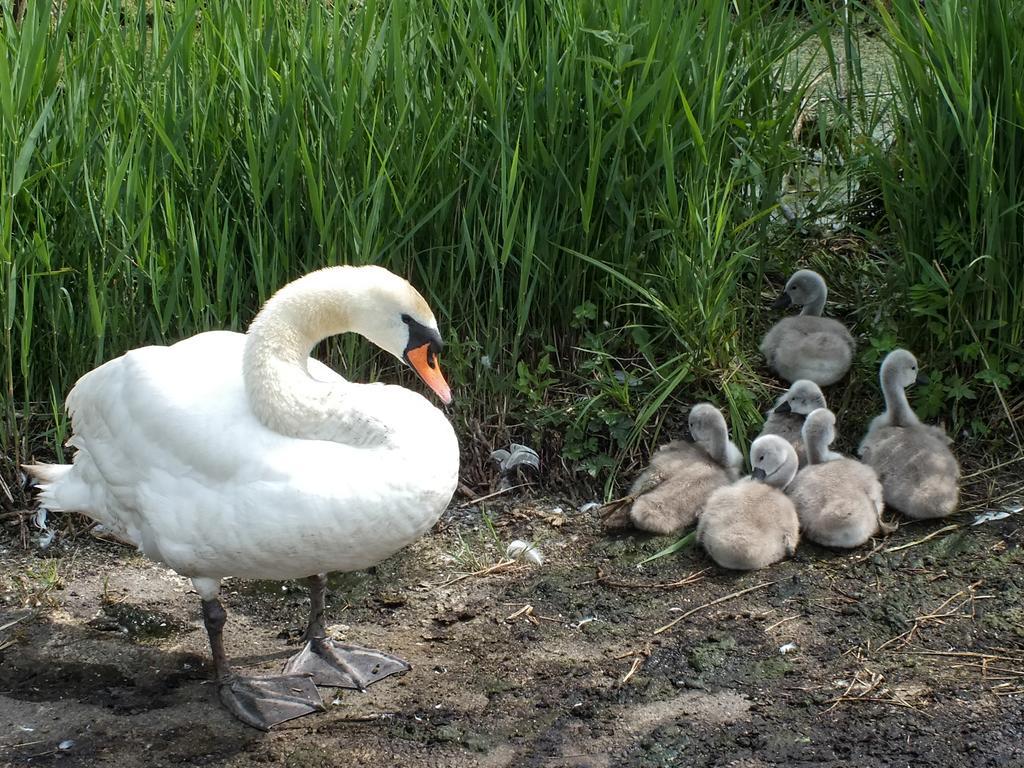Please provide a concise description of this image. As we can see in the image there are white color ducks and grass. 